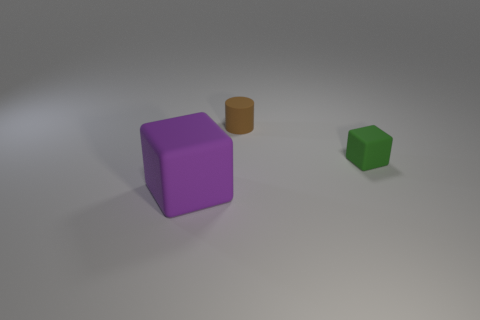How would the shadows of these objects change if the light source were moved to the opposite side? If the light source was moved to the opposite side, the shadows would also shift to the opposite side of each object relative to their current positions. The length and angles of the shadows would depend on the height and distance of the light source, but in general, we would see a mirrored effect of what we currently observe. 